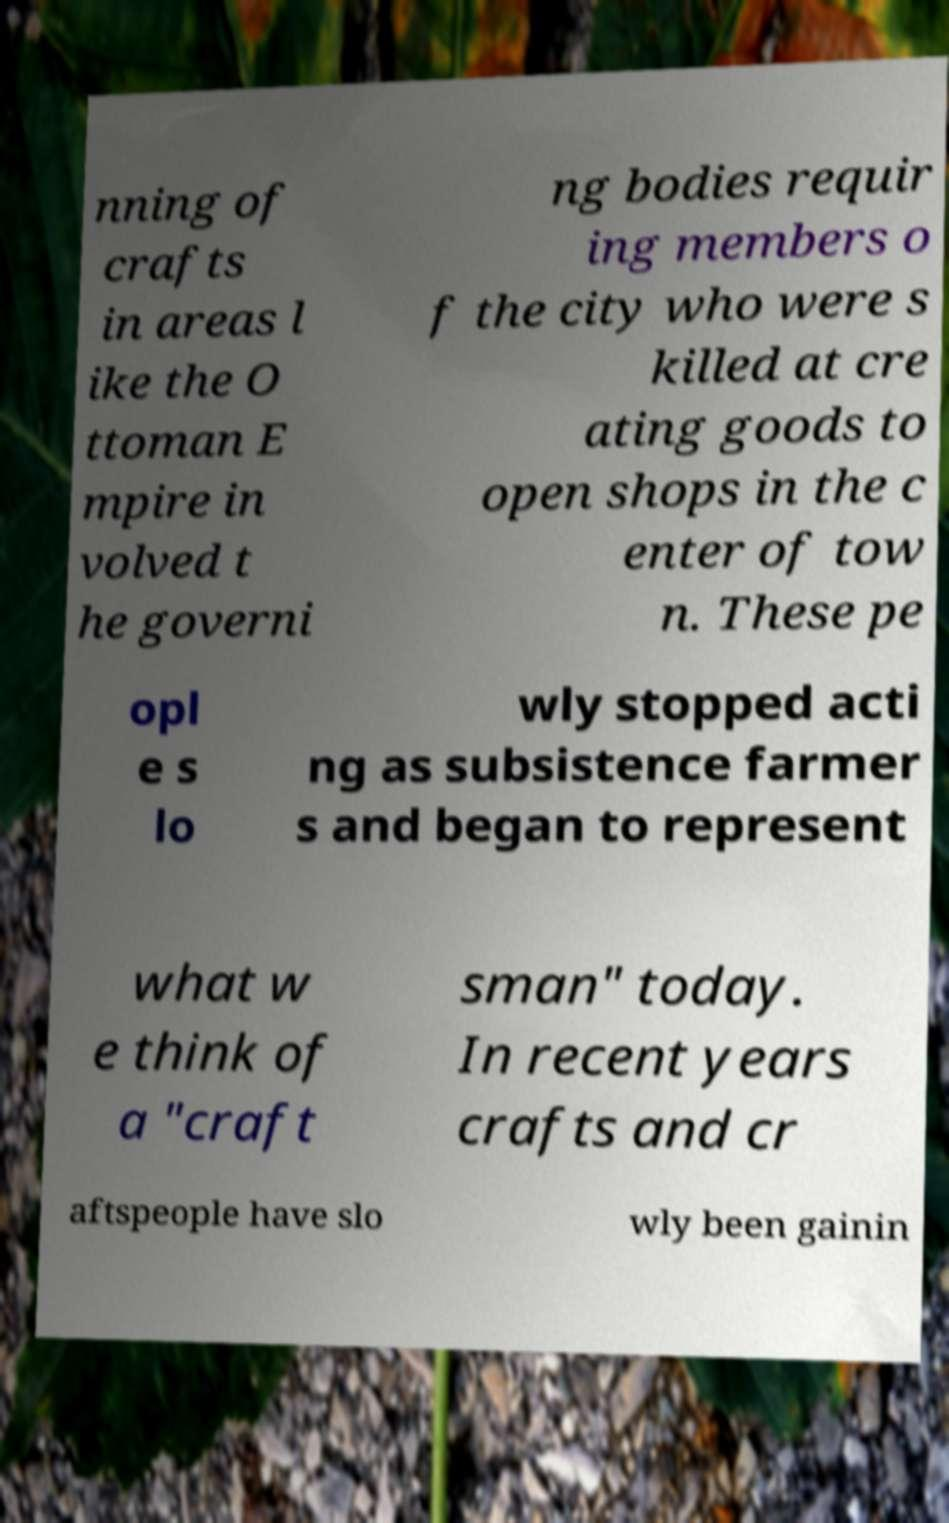Please identify and transcribe the text found in this image. nning of crafts in areas l ike the O ttoman E mpire in volved t he governi ng bodies requir ing members o f the city who were s killed at cre ating goods to open shops in the c enter of tow n. These pe opl e s lo wly stopped acti ng as subsistence farmer s and began to represent what w e think of a "craft sman" today. In recent years crafts and cr aftspeople have slo wly been gainin 